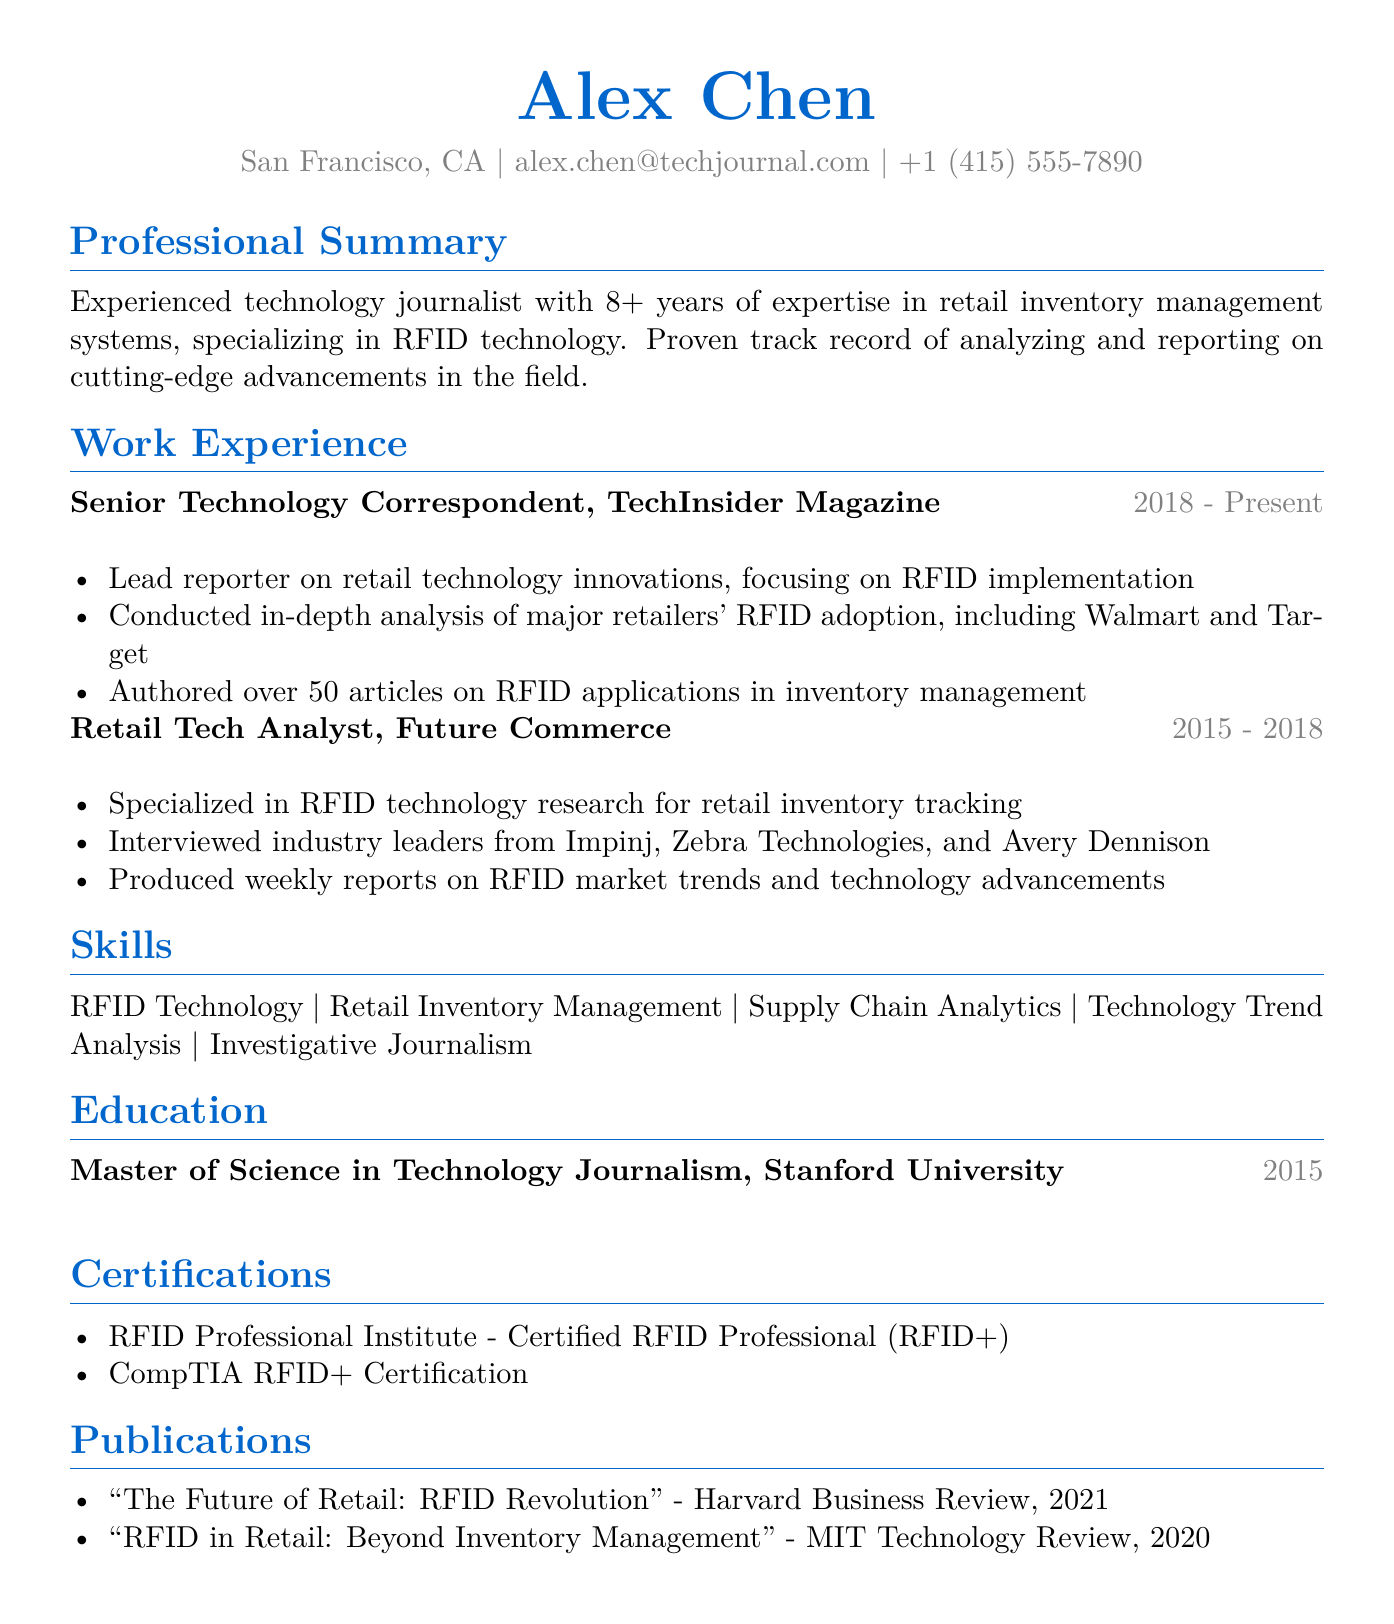what is the name of the individual? The individual's name is presented at the top of the document.
Answer: Alex Chen how many years of experience does the individual have? The document states the individual's experience in years in the professional summary.
Answer: 8+ what is the degree obtained by the individual? The individual's educational background lists their highest degree.
Answer: Master of Science in Technology Journalism where did the individual work as a Retail Tech Analyst? The work experience section specifies the location of the individual's previous job title.
Answer: New York, NY how many articles has the individual authored on RFID applications? The individual's responsibilities include a specific number of articles published.
Answer: over 50 name two certifications held by the individual. The certifications section lists specific qualifications the individual has obtained.
Answer: Certified RFID Professional (RFID+), CompTIA RFID+ Certification which magazine is the individual currently working for? The work experience section indicates the name of the current employer.
Answer: TechInsider Magazine what is one publication authored by the individual? The publications section lists several articles written by the individual.
Answer: "The Future of Retail: RFID Revolution" what years did the individual work at Future Commerce? The work experience section provides the duration of employment at this position.
Answer: 2015 - 2018 